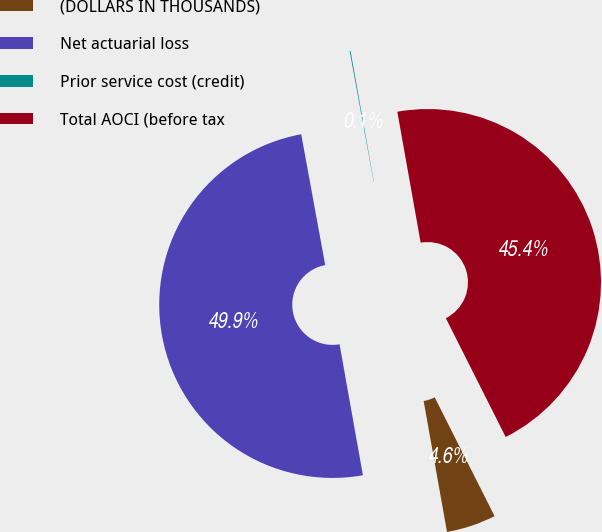<chart> <loc_0><loc_0><loc_500><loc_500><pie_chart><fcel>(DOLLARS IN THOUSANDS)<fcel>Net actuarial loss<fcel>Prior service cost (credit)<fcel>Total AOCI (before tax<nl><fcel>4.62%<fcel>49.92%<fcel>0.08%<fcel>45.38%<nl></chart> 